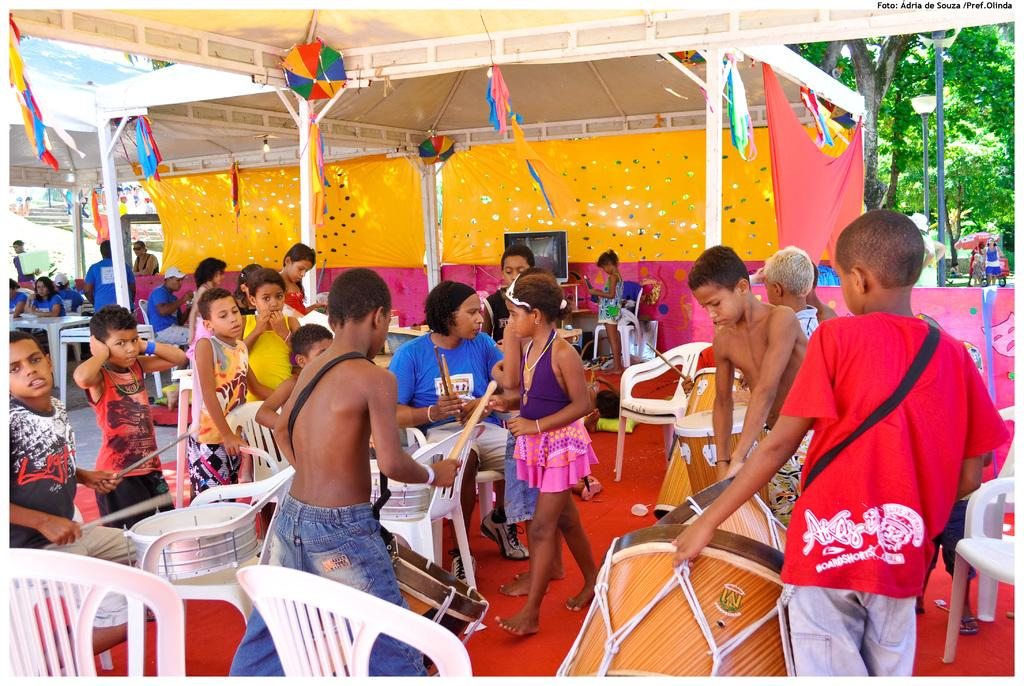What are the people in the image doing? There are persons standing and sitting in the image. What objects are present that might be used for sitting? Chairs are visible in the image. What else can be seen in the image besides people and chairs? Musical instruments are present in the image. What can be seen in the background of the image? There is a tent in the background of the image. What type of veil is draped over the musical instruments in the image? There is no veil present in the image; the musical instruments are not covered. 